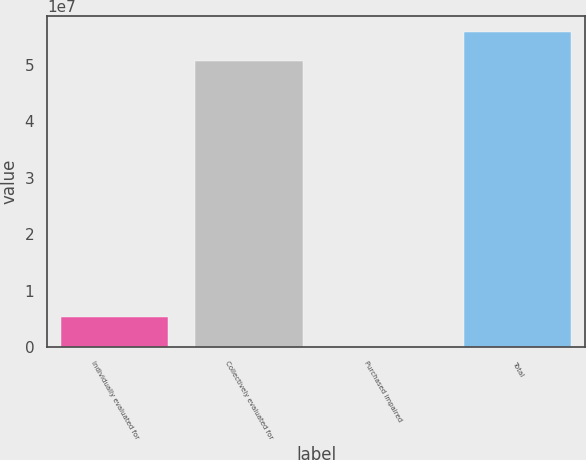Convert chart to OTSL. <chart><loc_0><loc_0><loc_500><loc_500><bar_chart><fcel>Individually evaluated for<fcel>Collectively evaluated for<fcel>Purchased impaired<fcel>Total<nl><fcel>5.28636e+06<fcel>5.06658e+07<fcel>97019<fcel>5.58551e+07<nl></chart> 